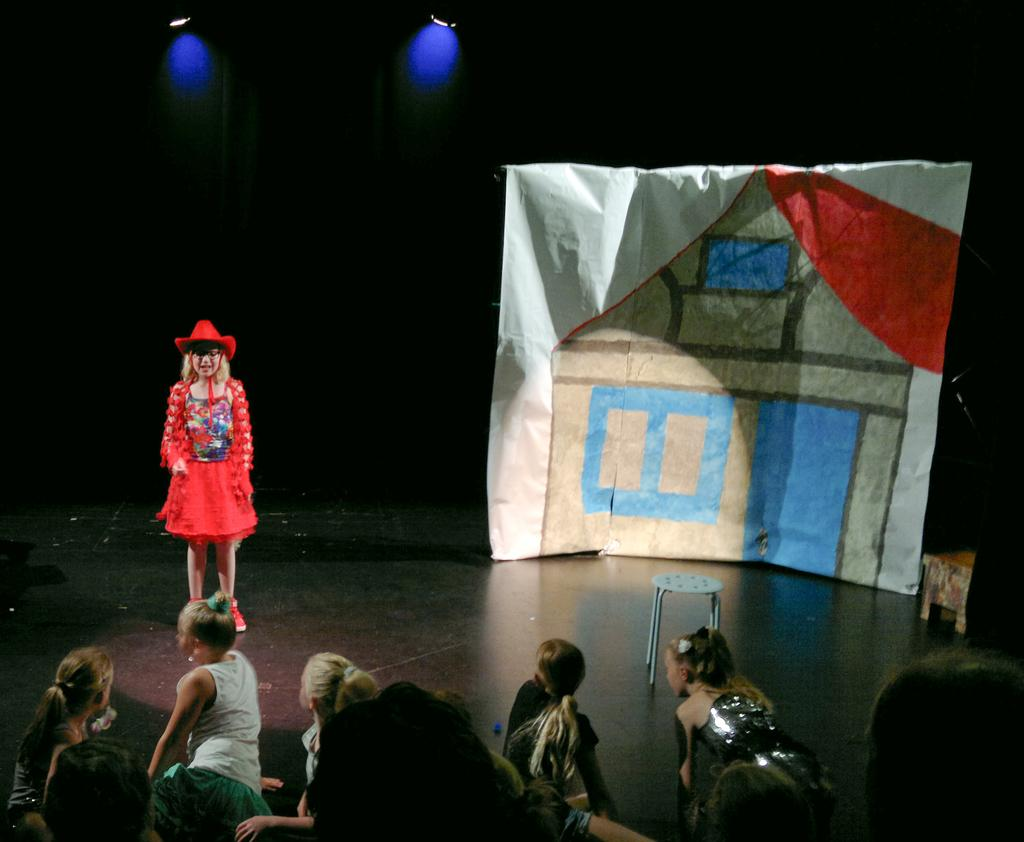How many people are in the image? There are people in the image, but the exact number is not specified. What is the woman doing in the image? The woman is standing on the floor in the image. What object is present in the image that can be used for sitting? There is a stool in the image that can be used for sitting. What is hanging in the image? There is a banner in the image. What is the color of the background in the image? The background of the image is dark. What can be seen providing illumination in the image? There are lights visible in the image. How many crates of profit can be seen in the image? There is no mention of crates or profit in the image, so it cannot be determined. What type of hen is sitting on the stool in the image? There is no hen present in the image; only people, a stool, and a banner are mentioned. 